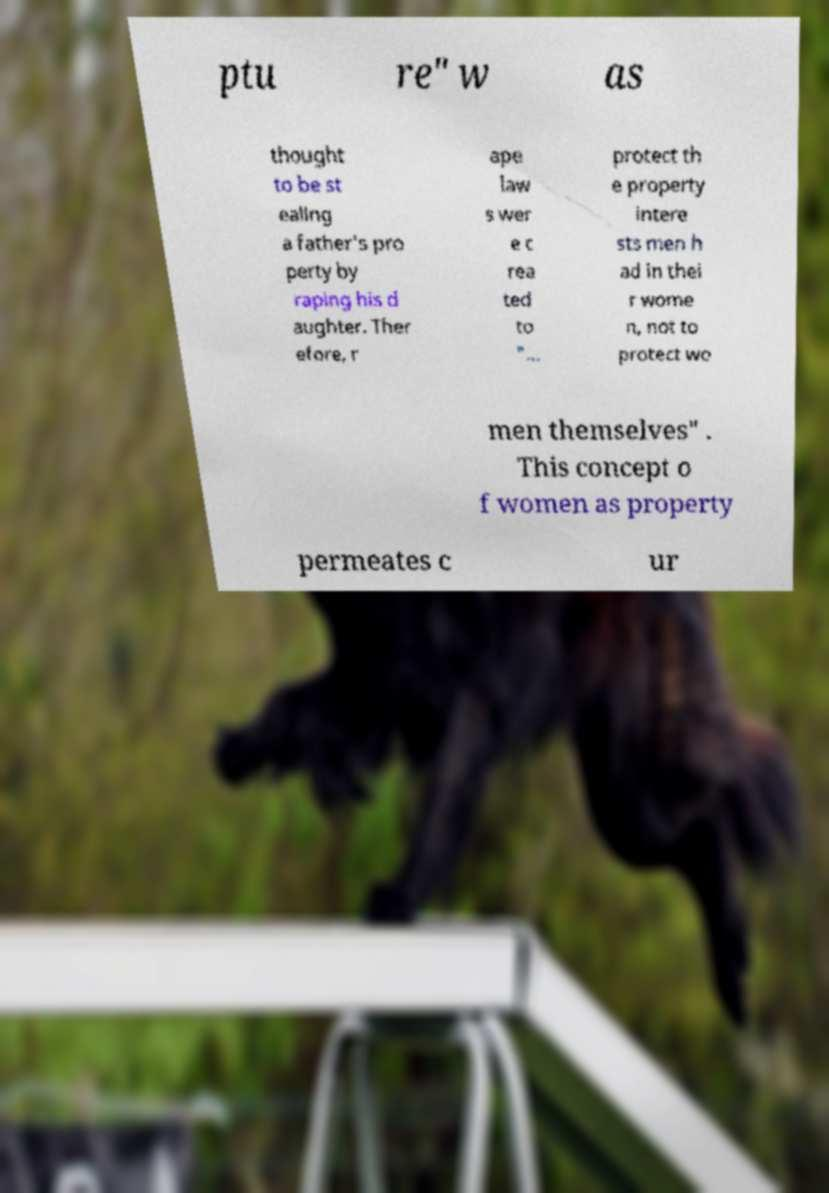There's text embedded in this image that I need extracted. Can you transcribe it verbatim? ptu re" w as thought to be st ealing a father's pro perty by raping his d aughter. Ther efore, r ape law s wer e c rea ted to "… protect th e property intere sts men h ad in thei r wome n, not to protect wo men themselves" . This concept o f women as property permeates c ur 